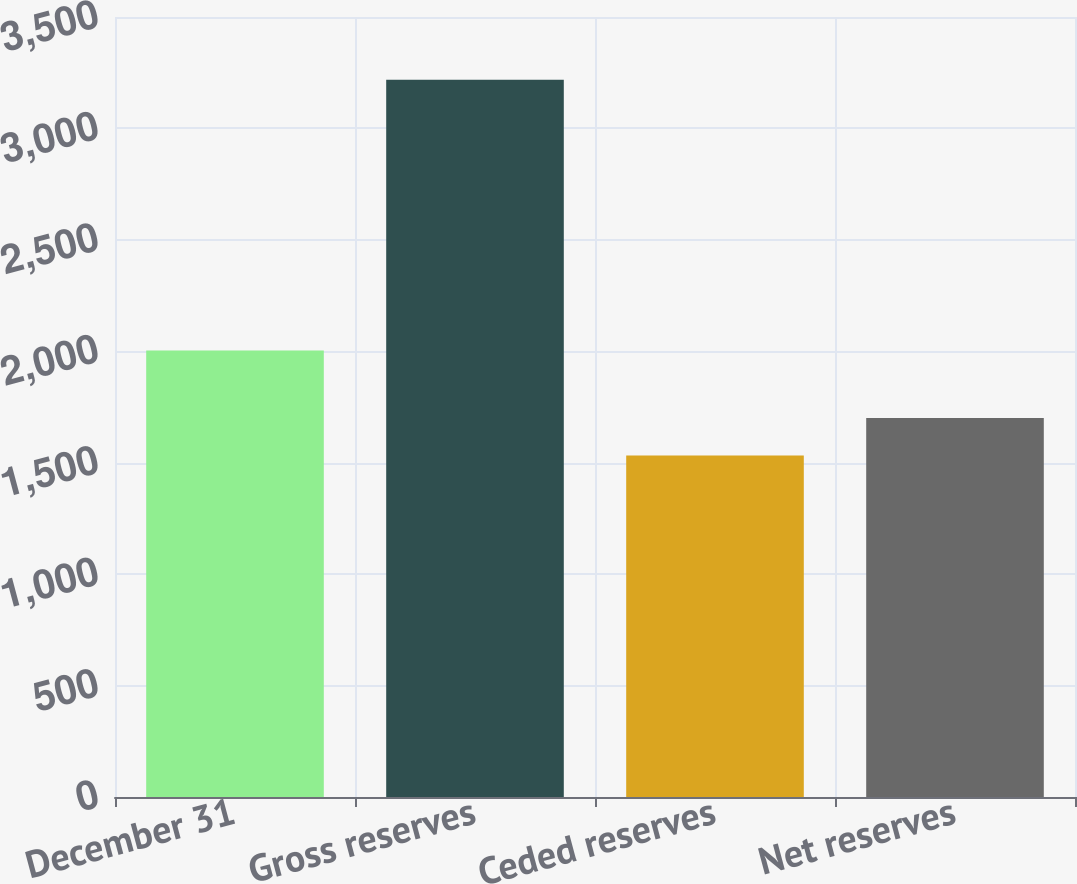Convert chart. <chart><loc_0><loc_0><loc_500><loc_500><bar_chart><fcel>December 31<fcel>Gross reserves<fcel>Ceded reserves<fcel>Net reserves<nl><fcel>2004<fcel>3218<fcel>1532<fcel>1700.6<nl></chart> 